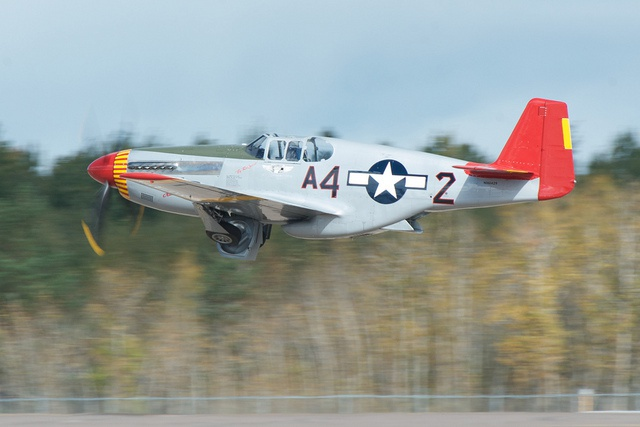Describe the objects in this image and their specific colors. I can see airplane in lightblue, lightgray, gray, red, and darkgray tones and people in lightblue, gray, and blue tones in this image. 